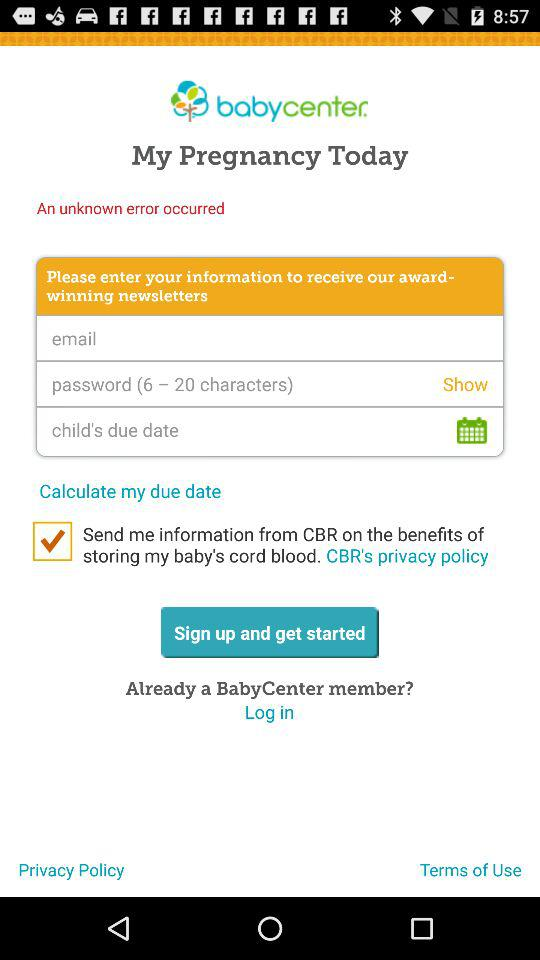What is the application name? The application name is "Baby Center: My Pregnancy Today". 